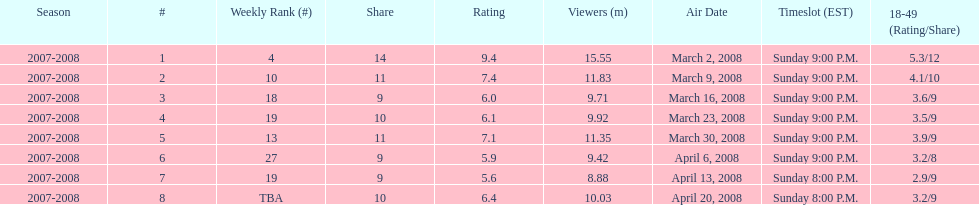What episode had the highest rating? March 2, 2008. 